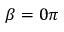Convert formula to latex. <formula><loc_0><loc_0><loc_500><loc_500>\beta = 0 \pi</formula> 